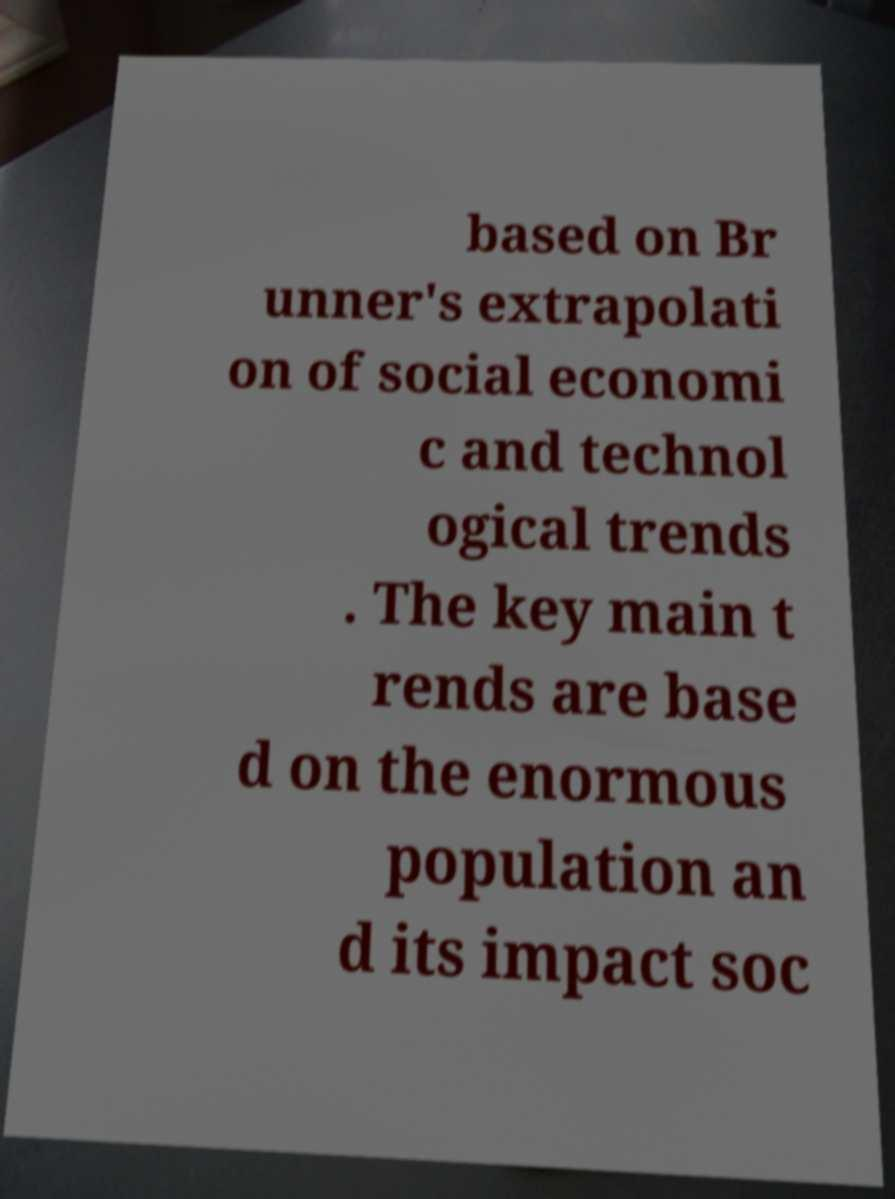Can you read and provide the text displayed in the image?This photo seems to have some interesting text. Can you extract and type it out for me? based on Br unner's extrapolati on of social economi c and technol ogical trends . The key main t rends are base d on the enormous population an d its impact soc 